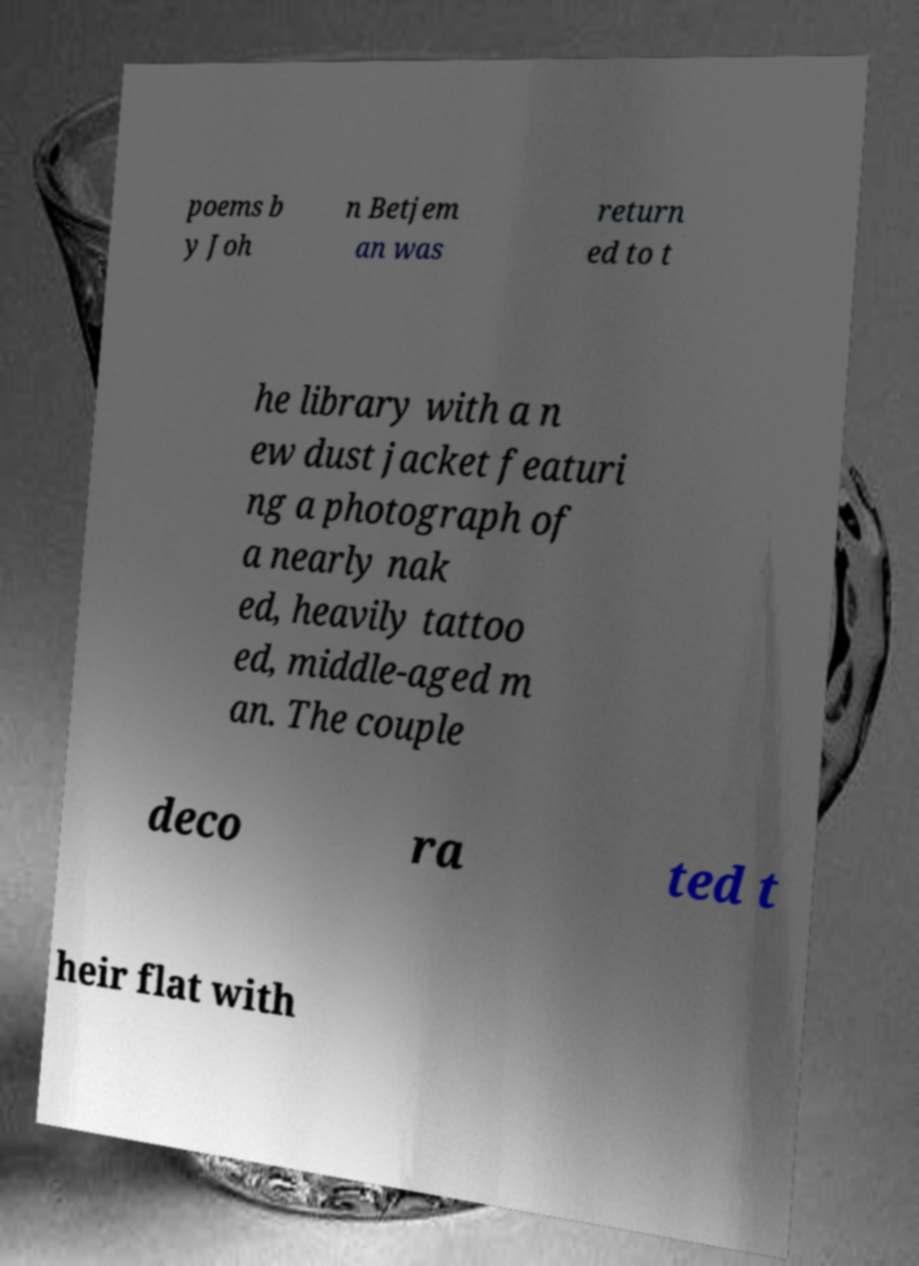Please read and relay the text visible in this image. What does it say? poems b y Joh n Betjem an was return ed to t he library with a n ew dust jacket featuri ng a photograph of a nearly nak ed, heavily tattoo ed, middle-aged m an. The couple deco ra ted t heir flat with 